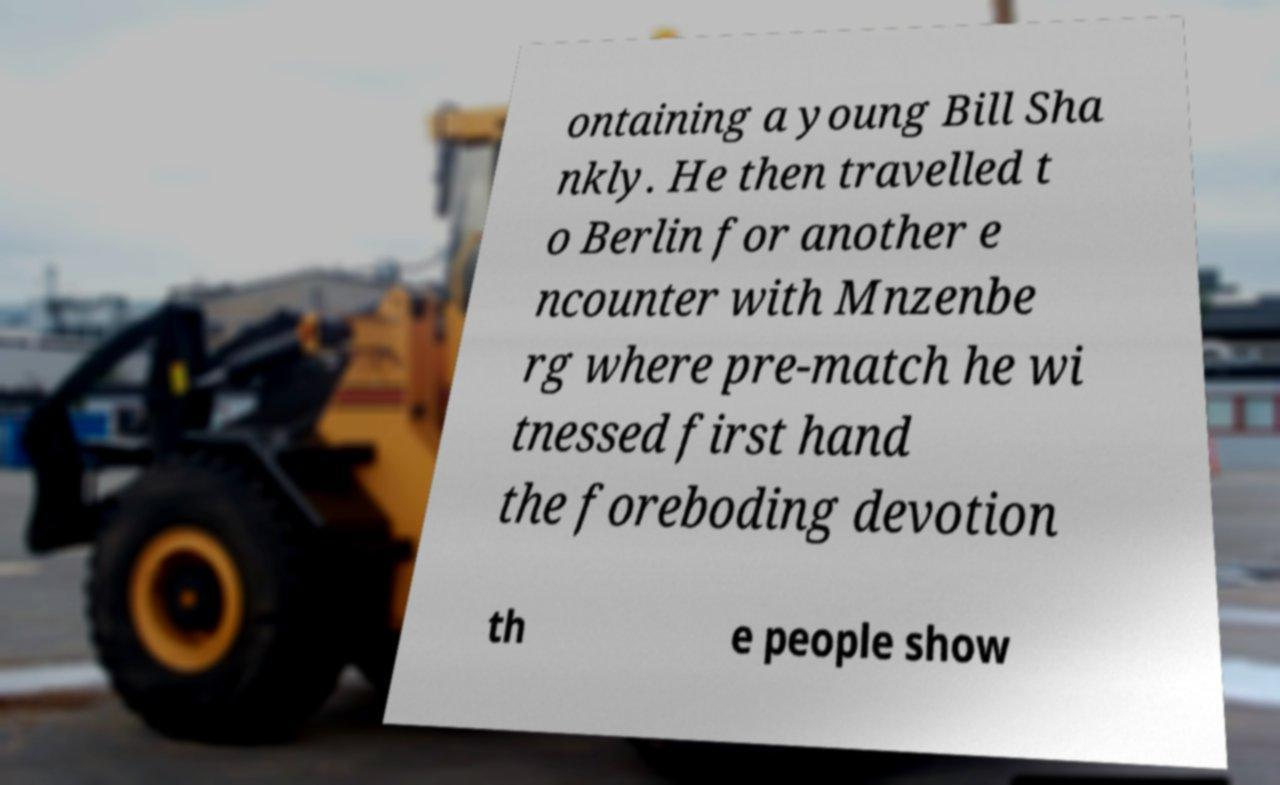Could you assist in decoding the text presented in this image and type it out clearly? ontaining a young Bill Sha nkly. He then travelled t o Berlin for another e ncounter with Mnzenbe rg where pre-match he wi tnessed first hand the foreboding devotion th e people show 